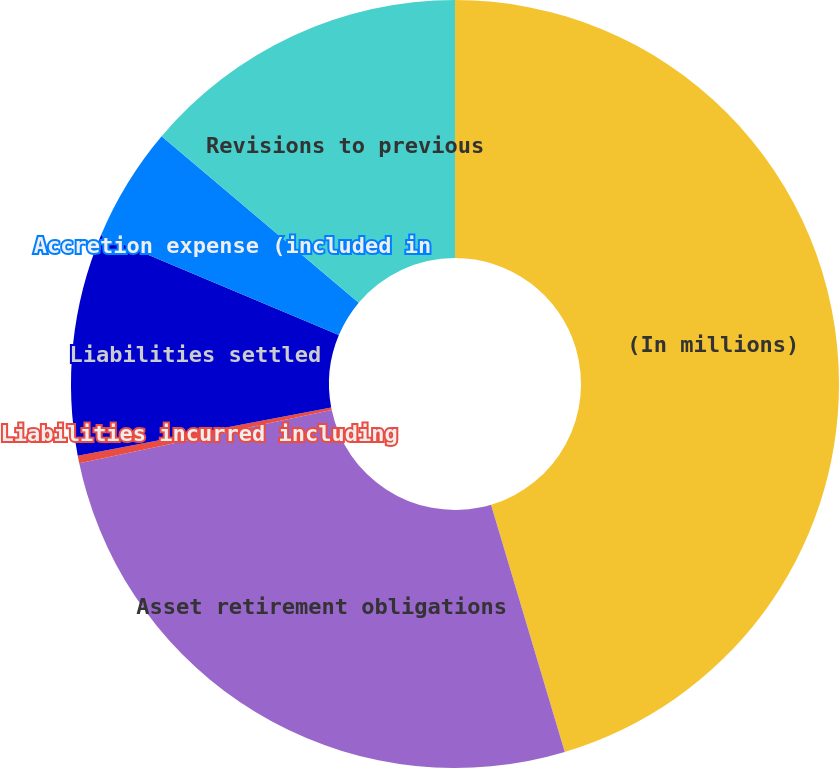Convert chart to OTSL. <chart><loc_0><loc_0><loc_500><loc_500><pie_chart><fcel>(In millions)<fcel>Asset retirement obligations<fcel>Liabilities incurred including<fcel>Liabilities settled<fcel>Accretion expense (included in<fcel>Revisions to previous<nl><fcel>45.39%<fcel>26.31%<fcel>0.32%<fcel>9.33%<fcel>4.82%<fcel>13.84%<nl></chart> 